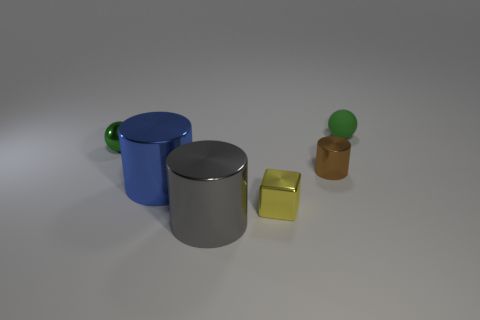Add 4 small purple rubber cubes. How many objects exist? 10 Subtract all spheres. How many objects are left? 4 Subtract 0 purple balls. How many objects are left? 6 Subtract all gray metallic cylinders. Subtract all cylinders. How many objects are left? 2 Add 2 small yellow metal things. How many small yellow metal things are left? 3 Add 3 tiny green metallic balls. How many tiny green metallic balls exist? 4 